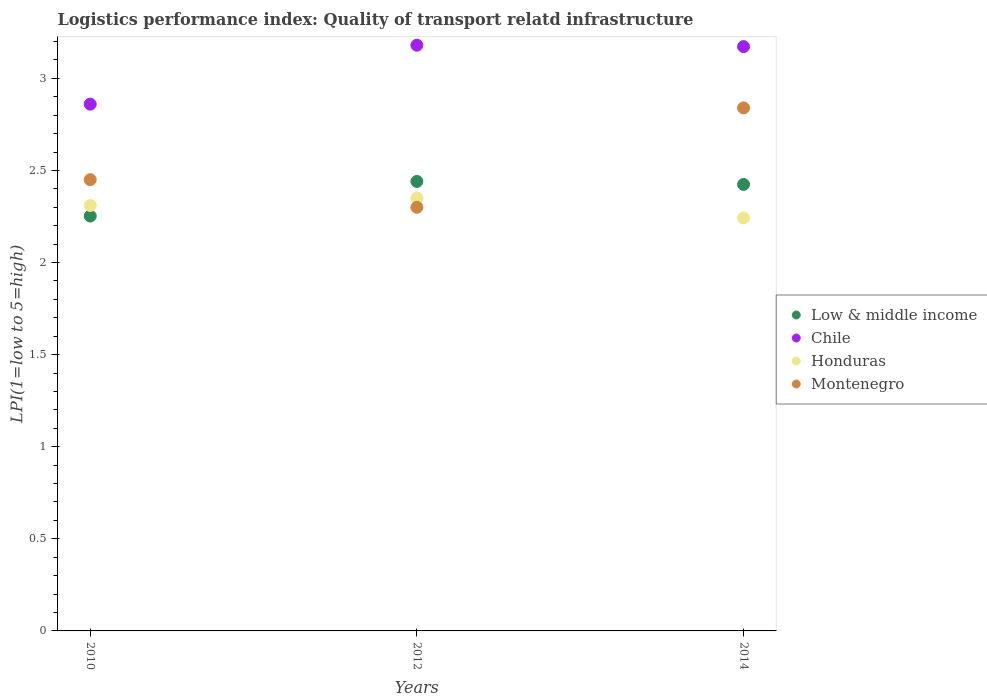How many different coloured dotlines are there?
Provide a succinct answer. 4. What is the logistics performance index in Chile in 2012?
Provide a short and direct response. 3.18. Across all years, what is the maximum logistics performance index in Low & middle income?
Make the answer very short. 2.44. Across all years, what is the minimum logistics performance index in Chile?
Give a very brief answer. 2.86. In which year was the logistics performance index in Chile maximum?
Make the answer very short. 2012. What is the total logistics performance index in Low & middle income in the graph?
Provide a succinct answer. 7.12. What is the difference between the logistics performance index in Montenegro in 2012 and that in 2014?
Offer a terse response. -0.54. What is the difference between the logistics performance index in Chile in 2012 and the logistics performance index in Honduras in 2010?
Offer a very short reply. 0.87. What is the average logistics performance index in Montenegro per year?
Your answer should be very brief. 2.53. In the year 2010, what is the difference between the logistics performance index in Montenegro and logistics performance index in Low & middle income?
Provide a short and direct response. 0.2. What is the ratio of the logistics performance index in Honduras in 2010 to that in 2014?
Offer a terse response. 1.03. Is the logistics performance index in Low & middle income in 2012 less than that in 2014?
Make the answer very short. No. What is the difference between the highest and the second highest logistics performance index in Chile?
Keep it short and to the point. 0.01. What is the difference between the highest and the lowest logistics performance index in Honduras?
Your response must be concise. 0.11. Is it the case that in every year, the sum of the logistics performance index in Montenegro and logistics performance index in Honduras  is greater than the sum of logistics performance index in Chile and logistics performance index in Low & middle income?
Provide a succinct answer. No. How many years are there in the graph?
Offer a terse response. 3. How many legend labels are there?
Provide a short and direct response. 4. How are the legend labels stacked?
Ensure brevity in your answer.  Vertical. What is the title of the graph?
Ensure brevity in your answer.  Logistics performance index: Quality of transport relatd infrastructure. What is the label or title of the Y-axis?
Give a very brief answer. LPI(1=low to 5=high). What is the LPI(1=low to 5=high) in Low & middle income in 2010?
Provide a succinct answer. 2.25. What is the LPI(1=low to 5=high) of Chile in 2010?
Your answer should be very brief. 2.86. What is the LPI(1=low to 5=high) in Honduras in 2010?
Ensure brevity in your answer.  2.31. What is the LPI(1=low to 5=high) of Montenegro in 2010?
Provide a short and direct response. 2.45. What is the LPI(1=low to 5=high) of Low & middle income in 2012?
Your response must be concise. 2.44. What is the LPI(1=low to 5=high) in Chile in 2012?
Provide a short and direct response. 3.18. What is the LPI(1=low to 5=high) of Honduras in 2012?
Keep it short and to the point. 2.35. What is the LPI(1=low to 5=high) in Montenegro in 2012?
Ensure brevity in your answer.  2.3. What is the LPI(1=low to 5=high) in Low & middle income in 2014?
Offer a very short reply. 2.42. What is the LPI(1=low to 5=high) in Chile in 2014?
Offer a terse response. 3.17. What is the LPI(1=low to 5=high) in Honduras in 2014?
Your response must be concise. 2.24. What is the LPI(1=low to 5=high) of Montenegro in 2014?
Make the answer very short. 2.84. Across all years, what is the maximum LPI(1=low to 5=high) in Low & middle income?
Offer a terse response. 2.44. Across all years, what is the maximum LPI(1=low to 5=high) of Chile?
Offer a terse response. 3.18. Across all years, what is the maximum LPI(1=low to 5=high) in Honduras?
Ensure brevity in your answer.  2.35. Across all years, what is the maximum LPI(1=low to 5=high) in Montenegro?
Provide a short and direct response. 2.84. Across all years, what is the minimum LPI(1=low to 5=high) of Low & middle income?
Your answer should be compact. 2.25. Across all years, what is the minimum LPI(1=low to 5=high) in Chile?
Give a very brief answer. 2.86. Across all years, what is the minimum LPI(1=low to 5=high) of Honduras?
Provide a succinct answer. 2.24. What is the total LPI(1=low to 5=high) of Low & middle income in the graph?
Ensure brevity in your answer.  7.12. What is the total LPI(1=low to 5=high) in Chile in the graph?
Provide a succinct answer. 9.21. What is the total LPI(1=low to 5=high) of Honduras in the graph?
Your response must be concise. 6.9. What is the total LPI(1=low to 5=high) in Montenegro in the graph?
Provide a succinct answer. 7.59. What is the difference between the LPI(1=low to 5=high) in Low & middle income in 2010 and that in 2012?
Ensure brevity in your answer.  -0.19. What is the difference between the LPI(1=low to 5=high) in Chile in 2010 and that in 2012?
Keep it short and to the point. -0.32. What is the difference between the LPI(1=low to 5=high) of Honduras in 2010 and that in 2012?
Keep it short and to the point. -0.04. What is the difference between the LPI(1=low to 5=high) of Low & middle income in 2010 and that in 2014?
Give a very brief answer. -0.17. What is the difference between the LPI(1=low to 5=high) of Chile in 2010 and that in 2014?
Offer a terse response. -0.31. What is the difference between the LPI(1=low to 5=high) of Honduras in 2010 and that in 2014?
Offer a very short reply. 0.07. What is the difference between the LPI(1=low to 5=high) in Montenegro in 2010 and that in 2014?
Offer a very short reply. -0.39. What is the difference between the LPI(1=low to 5=high) in Low & middle income in 2012 and that in 2014?
Your answer should be compact. 0.02. What is the difference between the LPI(1=low to 5=high) of Chile in 2012 and that in 2014?
Your answer should be compact. 0.01. What is the difference between the LPI(1=low to 5=high) of Honduras in 2012 and that in 2014?
Offer a very short reply. 0.11. What is the difference between the LPI(1=low to 5=high) of Montenegro in 2012 and that in 2014?
Offer a very short reply. -0.54. What is the difference between the LPI(1=low to 5=high) of Low & middle income in 2010 and the LPI(1=low to 5=high) of Chile in 2012?
Provide a succinct answer. -0.93. What is the difference between the LPI(1=low to 5=high) of Low & middle income in 2010 and the LPI(1=low to 5=high) of Honduras in 2012?
Keep it short and to the point. -0.1. What is the difference between the LPI(1=low to 5=high) of Low & middle income in 2010 and the LPI(1=low to 5=high) of Montenegro in 2012?
Ensure brevity in your answer.  -0.05. What is the difference between the LPI(1=low to 5=high) of Chile in 2010 and the LPI(1=low to 5=high) of Honduras in 2012?
Keep it short and to the point. 0.51. What is the difference between the LPI(1=low to 5=high) in Chile in 2010 and the LPI(1=low to 5=high) in Montenegro in 2012?
Provide a short and direct response. 0.56. What is the difference between the LPI(1=low to 5=high) of Low & middle income in 2010 and the LPI(1=low to 5=high) of Chile in 2014?
Your answer should be compact. -0.92. What is the difference between the LPI(1=low to 5=high) of Low & middle income in 2010 and the LPI(1=low to 5=high) of Honduras in 2014?
Your response must be concise. 0.01. What is the difference between the LPI(1=low to 5=high) of Low & middle income in 2010 and the LPI(1=low to 5=high) of Montenegro in 2014?
Your answer should be compact. -0.59. What is the difference between the LPI(1=low to 5=high) of Chile in 2010 and the LPI(1=low to 5=high) of Honduras in 2014?
Your answer should be very brief. 0.62. What is the difference between the LPI(1=low to 5=high) of Chile in 2010 and the LPI(1=low to 5=high) of Montenegro in 2014?
Keep it short and to the point. 0.02. What is the difference between the LPI(1=low to 5=high) in Honduras in 2010 and the LPI(1=low to 5=high) in Montenegro in 2014?
Give a very brief answer. -0.53. What is the difference between the LPI(1=low to 5=high) in Low & middle income in 2012 and the LPI(1=low to 5=high) in Chile in 2014?
Provide a succinct answer. -0.73. What is the difference between the LPI(1=low to 5=high) of Low & middle income in 2012 and the LPI(1=low to 5=high) of Honduras in 2014?
Offer a terse response. 0.2. What is the difference between the LPI(1=low to 5=high) in Low & middle income in 2012 and the LPI(1=low to 5=high) in Montenegro in 2014?
Make the answer very short. -0.4. What is the difference between the LPI(1=low to 5=high) in Chile in 2012 and the LPI(1=low to 5=high) in Montenegro in 2014?
Ensure brevity in your answer.  0.34. What is the difference between the LPI(1=low to 5=high) in Honduras in 2012 and the LPI(1=low to 5=high) in Montenegro in 2014?
Provide a short and direct response. -0.49. What is the average LPI(1=low to 5=high) of Low & middle income per year?
Your answer should be compact. 2.37. What is the average LPI(1=low to 5=high) of Chile per year?
Your answer should be very brief. 3.07. What is the average LPI(1=low to 5=high) in Honduras per year?
Your answer should be compact. 2.3. What is the average LPI(1=low to 5=high) in Montenegro per year?
Offer a very short reply. 2.53. In the year 2010, what is the difference between the LPI(1=low to 5=high) of Low & middle income and LPI(1=low to 5=high) of Chile?
Offer a very short reply. -0.61. In the year 2010, what is the difference between the LPI(1=low to 5=high) of Low & middle income and LPI(1=low to 5=high) of Honduras?
Offer a terse response. -0.06. In the year 2010, what is the difference between the LPI(1=low to 5=high) in Low & middle income and LPI(1=low to 5=high) in Montenegro?
Keep it short and to the point. -0.2. In the year 2010, what is the difference between the LPI(1=low to 5=high) in Chile and LPI(1=low to 5=high) in Honduras?
Your answer should be compact. 0.55. In the year 2010, what is the difference between the LPI(1=low to 5=high) of Chile and LPI(1=low to 5=high) of Montenegro?
Keep it short and to the point. 0.41. In the year 2010, what is the difference between the LPI(1=low to 5=high) of Honduras and LPI(1=low to 5=high) of Montenegro?
Your answer should be very brief. -0.14. In the year 2012, what is the difference between the LPI(1=low to 5=high) in Low & middle income and LPI(1=low to 5=high) in Chile?
Ensure brevity in your answer.  -0.74. In the year 2012, what is the difference between the LPI(1=low to 5=high) of Low & middle income and LPI(1=low to 5=high) of Honduras?
Give a very brief answer. 0.09. In the year 2012, what is the difference between the LPI(1=low to 5=high) in Low & middle income and LPI(1=low to 5=high) in Montenegro?
Ensure brevity in your answer.  0.14. In the year 2012, what is the difference between the LPI(1=low to 5=high) in Chile and LPI(1=low to 5=high) in Honduras?
Ensure brevity in your answer.  0.83. In the year 2012, what is the difference between the LPI(1=low to 5=high) of Chile and LPI(1=low to 5=high) of Montenegro?
Your answer should be compact. 0.88. In the year 2012, what is the difference between the LPI(1=low to 5=high) in Honduras and LPI(1=low to 5=high) in Montenegro?
Your answer should be very brief. 0.05. In the year 2014, what is the difference between the LPI(1=low to 5=high) in Low & middle income and LPI(1=low to 5=high) in Chile?
Make the answer very short. -0.75. In the year 2014, what is the difference between the LPI(1=low to 5=high) in Low & middle income and LPI(1=low to 5=high) in Honduras?
Your answer should be compact. 0.18. In the year 2014, what is the difference between the LPI(1=low to 5=high) of Low & middle income and LPI(1=low to 5=high) of Montenegro?
Make the answer very short. -0.42. In the year 2014, what is the difference between the LPI(1=low to 5=high) in Chile and LPI(1=low to 5=high) in Montenegro?
Your answer should be compact. 0.33. In the year 2014, what is the difference between the LPI(1=low to 5=high) of Honduras and LPI(1=low to 5=high) of Montenegro?
Keep it short and to the point. -0.6. What is the ratio of the LPI(1=low to 5=high) in Low & middle income in 2010 to that in 2012?
Offer a very short reply. 0.92. What is the ratio of the LPI(1=low to 5=high) in Chile in 2010 to that in 2012?
Your response must be concise. 0.9. What is the ratio of the LPI(1=low to 5=high) in Montenegro in 2010 to that in 2012?
Your answer should be very brief. 1.07. What is the ratio of the LPI(1=low to 5=high) in Low & middle income in 2010 to that in 2014?
Make the answer very short. 0.93. What is the ratio of the LPI(1=low to 5=high) in Chile in 2010 to that in 2014?
Offer a terse response. 0.9. What is the ratio of the LPI(1=low to 5=high) of Honduras in 2010 to that in 2014?
Offer a terse response. 1.03. What is the ratio of the LPI(1=low to 5=high) of Montenegro in 2010 to that in 2014?
Offer a very short reply. 0.86. What is the ratio of the LPI(1=low to 5=high) in Low & middle income in 2012 to that in 2014?
Your answer should be very brief. 1.01. What is the ratio of the LPI(1=low to 5=high) of Chile in 2012 to that in 2014?
Ensure brevity in your answer.  1. What is the ratio of the LPI(1=low to 5=high) in Honduras in 2012 to that in 2014?
Ensure brevity in your answer.  1.05. What is the ratio of the LPI(1=low to 5=high) of Montenegro in 2012 to that in 2014?
Make the answer very short. 0.81. What is the difference between the highest and the second highest LPI(1=low to 5=high) in Low & middle income?
Your answer should be compact. 0.02. What is the difference between the highest and the second highest LPI(1=low to 5=high) in Chile?
Give a very brief answer. 0.01. What is the difference between the highest and the second highest LPI(1=low to 5=high) of Honduras?
Keep it short and to the point. 0.04. What is the difference between the highest and the second highest LPI(1=low to 5=high) of Montenegro?
Give a very brief answer. 0.39. What is the difference between the highest and the lowest LPI(1=low to 5=high) in Low & middle income?
Ensure brevity in your answer.  0.19. What is the difference between the highest and the lowest LPI(1=low to 5=high) in Chile?
Offer a very short reply. 0.32. What is the difference between the highest and the lowest LPI(1=low to 5=high) of Honduras?
Give a very brief answer. 0.11. What is the difference between the highest and the lowest LPI(1=low to 5=high) of Montenegro?
Offer a very short reply. 0.54. 